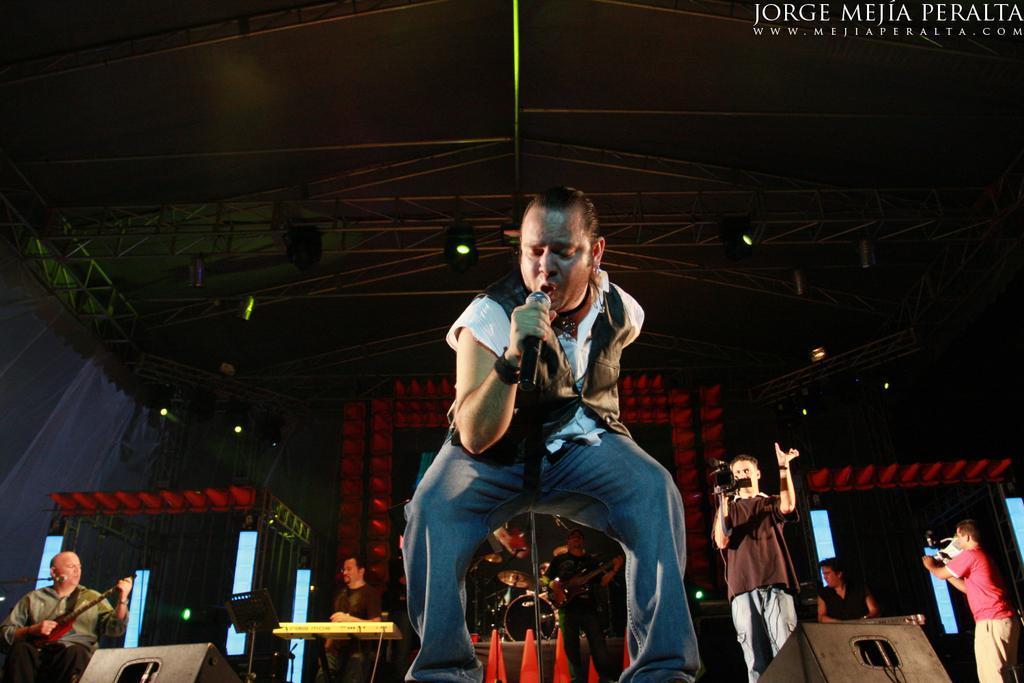Please provide a concise description of this image. There is a man standing on the stage holding a microphone singing and it behind him there are so many people playing musical instruments on the stage. 